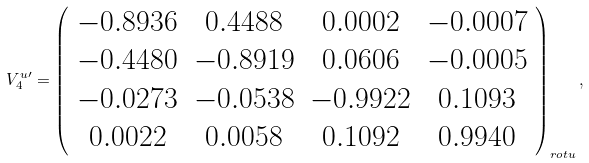Convert formula to latex. <formula><loc_0><loc_0><loc_500><loc_500>V _ { 4 } ^ { u \prime } = \left ( \begin{array} { c c c c } - 0 . 8 9 3 6 & 0 . 4 4 8 8 & 0 . 0 0 0 2 & - 0 . 0 0 0 7 \\ - 0 . 4 4 8 0 & - 0 . 8 9 1 9 & 0 . 0 6 0 6 & - 0 . 0 0 0 5 \\ - 0 . 0 2 7 3 & - 0 . 0 5 3 8 & - 0 . 9 9 2 2 & 0 . 1 0 9 3 \\ 0 . 0 0 2 2 & 0 . 0 0 5 8 & 0 . 1 0 9 2 & 0 . 9 9 4 0 \end{array} \right ) _ { r o t u } ,</formula> 